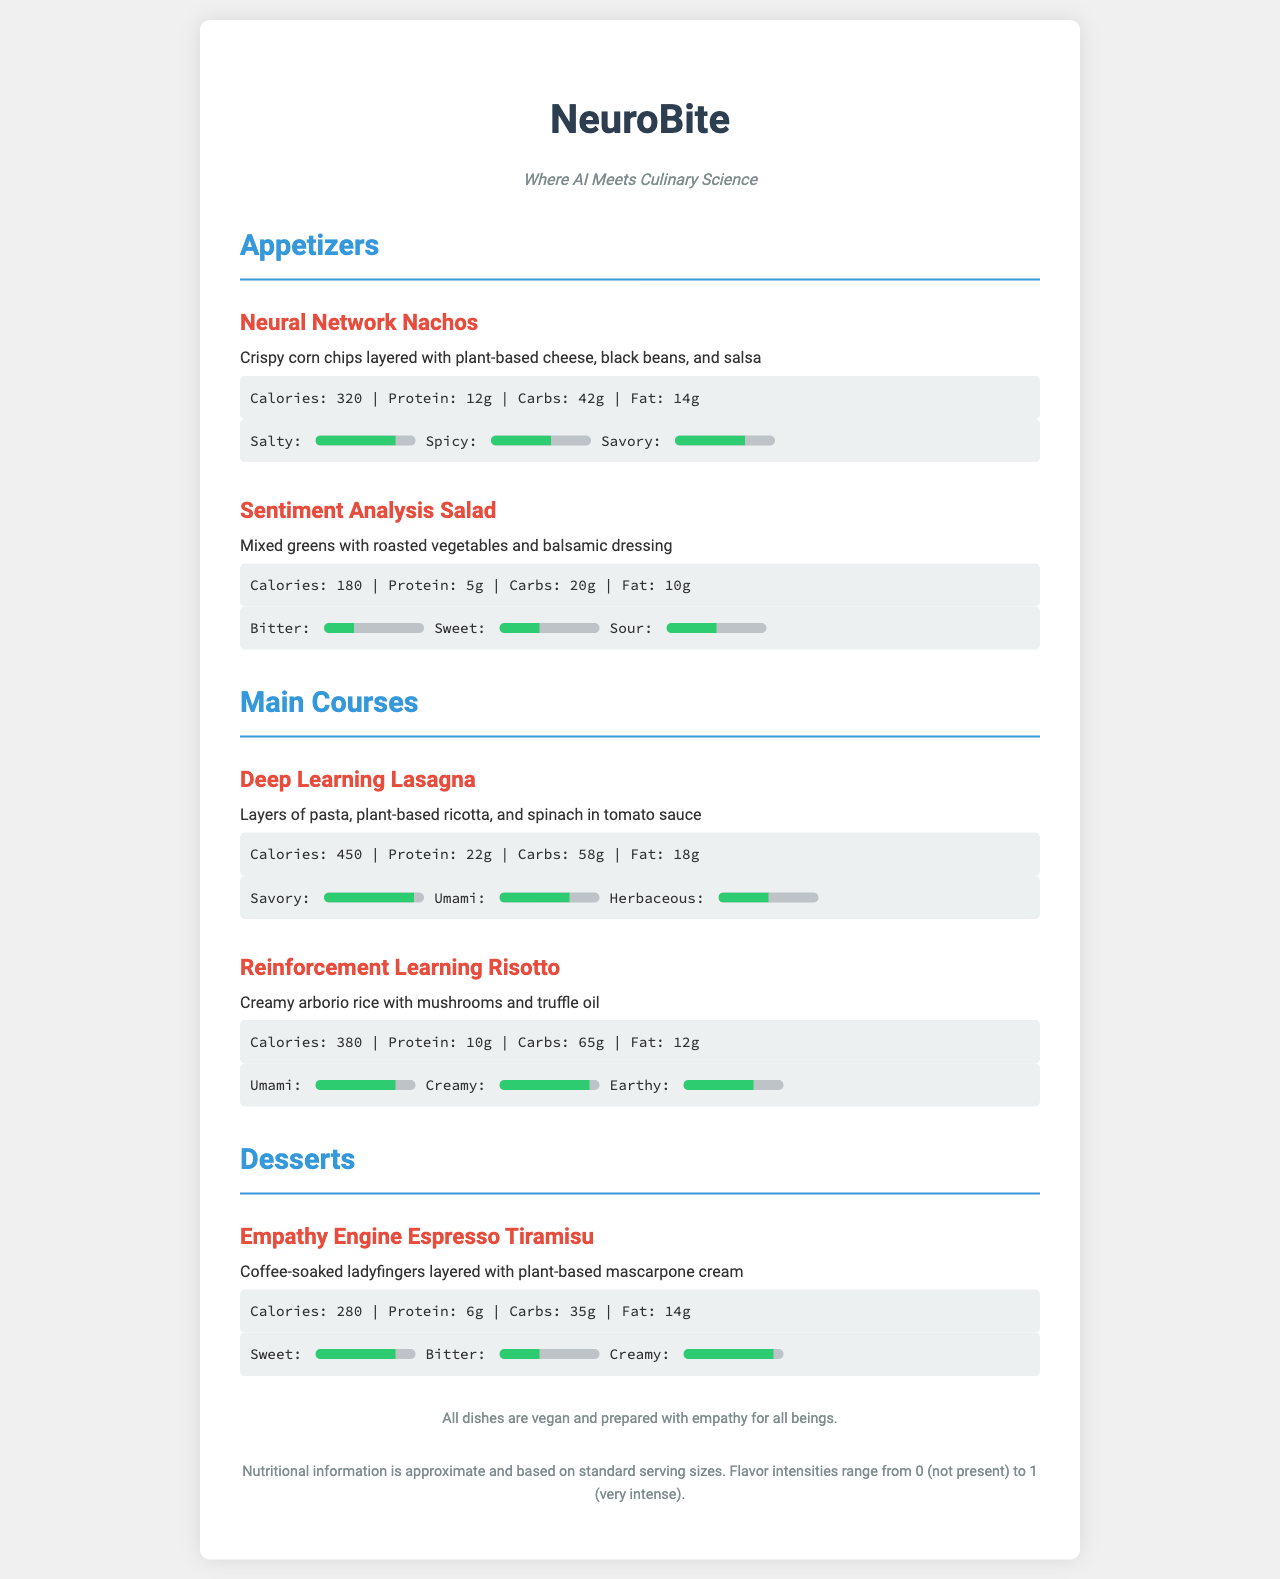What are the calories in Neural Network Nachos? The nutritional information states that Neural Network Nachos have 320 calories.
Answer: 320 What is the main ingredient in Deep Learning Lasagna? The description mentions layers of pasta, plant-based ricotta, and spinach.
Answer: Plant-based ricotta How much protein is in Reinforcement Learning Risotto? The nutritional info for Reinforcement Learning Risotto indicates it contains 10g of protein.
Answer: 10g Which appetizer has the highest savory flavor intensity? Comparing the flavor profiles, Neural Network Nachos have a savory intensity of 70%, which is the highest among appetizers.
Answer: Neural Network Nachos How many grams of carbs are in Sentiment Analysis Salad? The nutritional information specifies that Sentiment Analysis Salad contains 20g of carbs.
Answer: 20g What dessert has the lowest fat content? By looking at the nutritional info, the Empathy Engine Espresso Tiramisu has 14g of fat, which is lower than others listed.
Answer: 14g Which dish has the highest calorie count? Comparing the calories, Deep Learning Lasagna has the highest at 450 calories.
Answer: 450 What flavor is most predominant in Empathy Engine Espresso Tiramisu? The flavor profile shows that Sweet is 80%, which is most dominant in Empathy Engine Espresso Tiramisu.
Answer: Sweet How many dishes are mentioned in the Main Courses section? There are two dishes listed under the Main Courses: Deep Learning Lasagna and Reinforcement Learning Risotto.
Answer: 2 